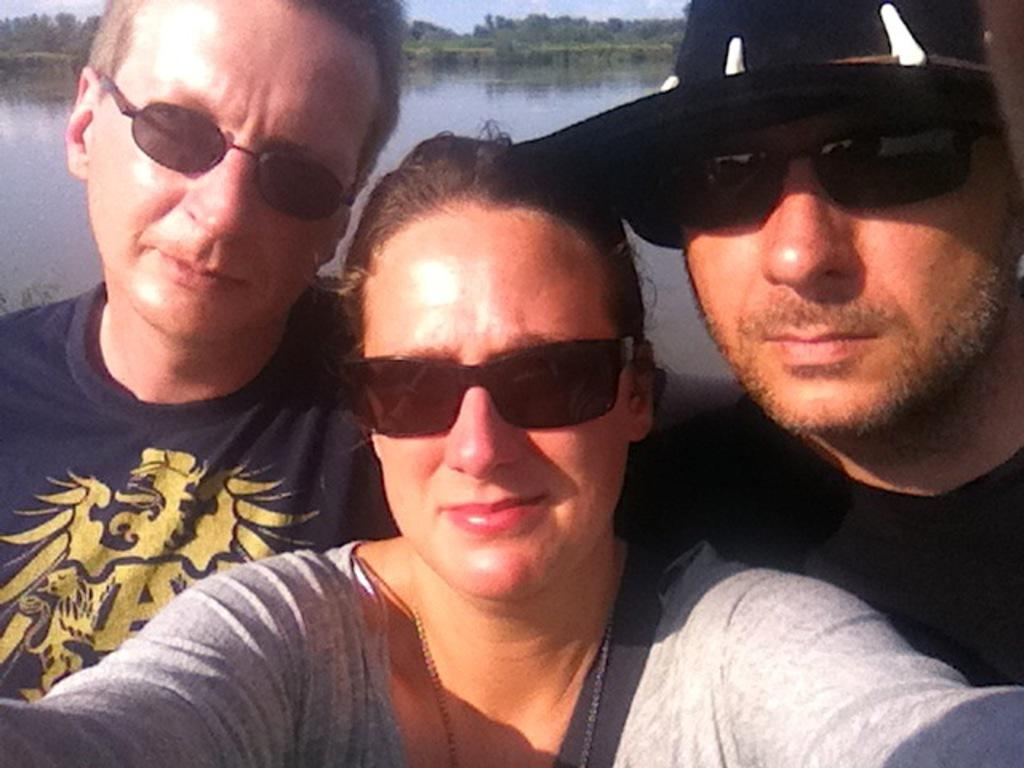How many people are in the image? There are three persons in the image. What are the persons wearing? The persons are wearing clothes and sunglasses. What can be seen in the background of the image? The image shows a lake in the background. What type of advertisement is being discussed by the persons in the image? There is no indication in the image that the persons are discussing an advertisement. 